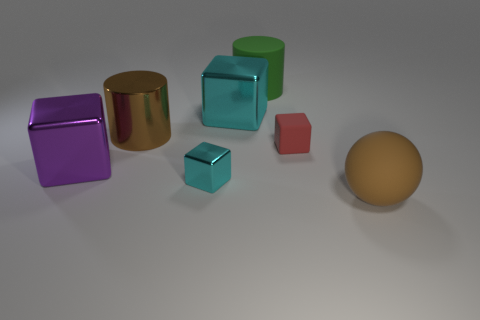Subtract 1 blocks. How many blocks are left? 3 Add 2 big cubes. How many objects exist? 9 Subtract all cylinders. How many objects are left? 5 Add 7 purple matte cylinders. How many purple matte cylinders exist? 7 Subtract 0 cyan spheres. How many objects are left? 7 Subtract all big brown things. Subtract all big brown matte things. How many objects are left? 4 Add 2 big metal objects. How many big metal objects are left? 5 